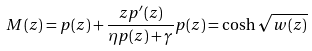Convert formula to latex. <formula><loc_0><loc_0><loc_500><loc_500>M ( z ) = p ( z ) + \frac { z p ^ { \prime } ( z ) } { \eta p ( z ) + \gamma } p ( z ) = \cosh \sqrt { w ( z ) }</formula> 